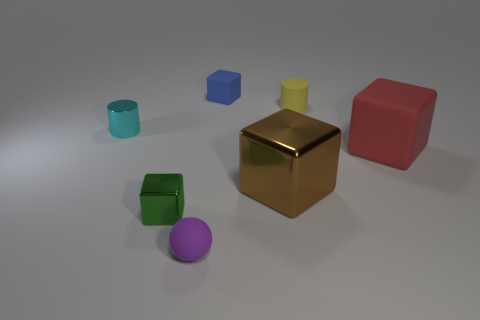Add 1 red matte blocks. How many objects exist? 8 Subtract all spheres. How many objects are left? 6 Subtract 1 purple balls. How many objects are left? 6 Subtract all small gray shiny objects. Subtract all tiny yellow matte cylinders. How many objects are left? 6 Add 5 tiny blue matte objects. How many tiny blue matte objects are left? 6 Add 5 yellow matte cylinders. How many yellow matte cylinders exist? 6 